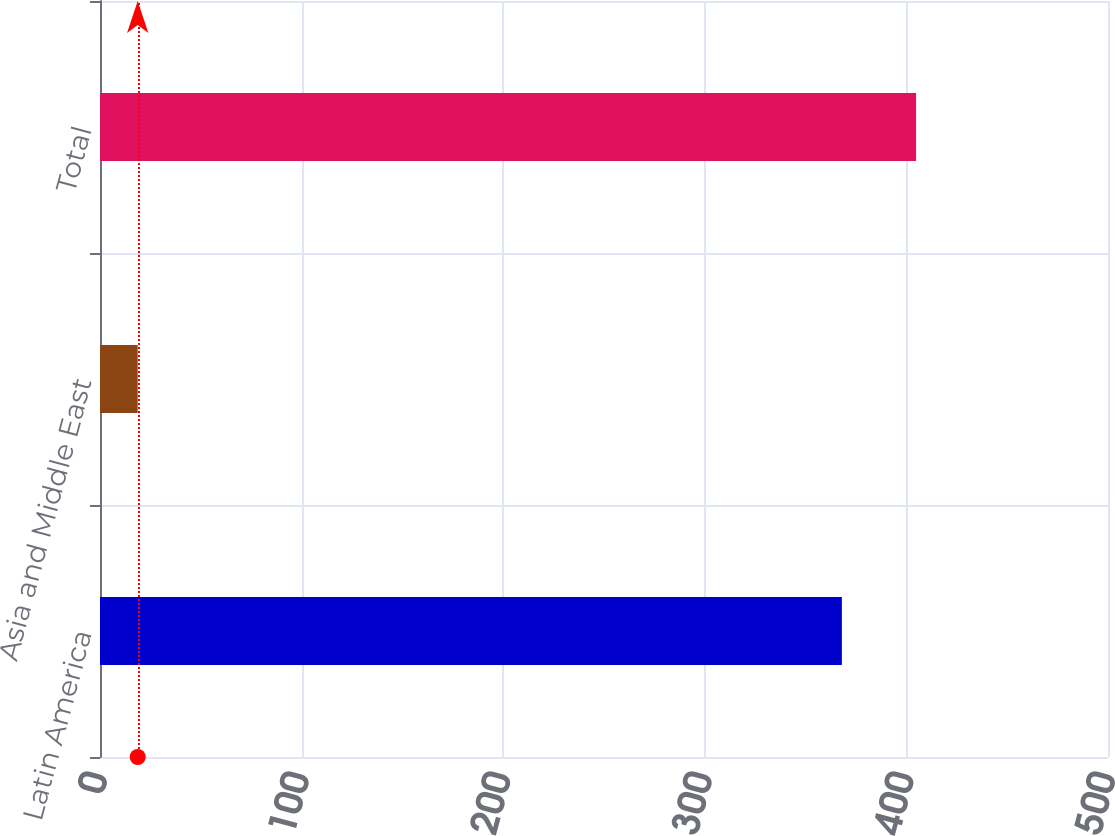Convert chart to OTSL. <chart><loc_0><loc_0><loc_500><loc_500><bar_chart><fcel>Latin America<fcel>Asia and Middle East<fcel>Total<nl><fcel>368<fcel>18.7<fcel>404.8<nl></chart> 